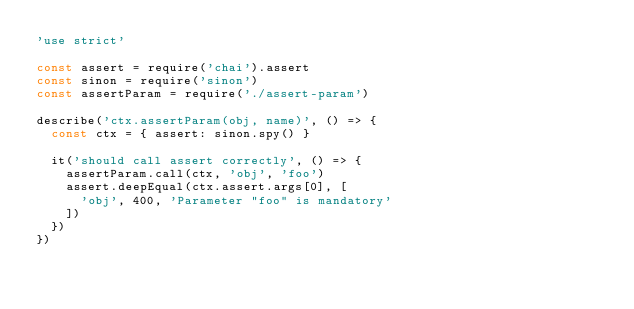Convert code to text. <code><loc_0><loc_0><loc_500><loc_500><_JavaScript_>'use strict'

const assert = require('chai').assert
const sinon = require('sinon')
const assertParam = require('./assert-param')

describe('ctx.assertParam(obj, name)', () => {
  const ctx = { assert: sinon.spy() }

  it('should call assert correctly', () => {
    assertParam.call(ctx, 'obj', 'foo')
    assert.deepEqual(ctx.assert.args[0], [
      'obj', 400, 'Parameter "foo" is mandatory'
    ])
  })
})
</code> 